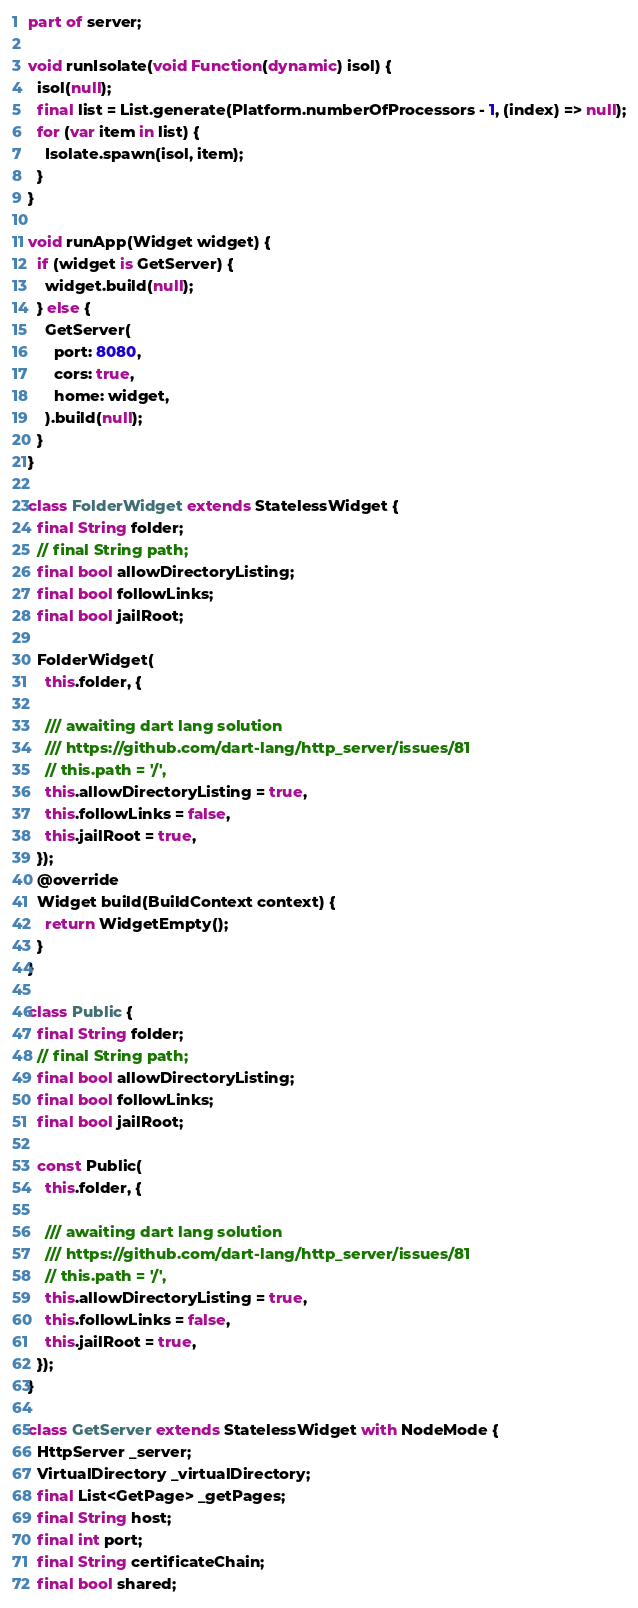Convert code to text. <code><loc_0><loc_0><loc_500><loc_500><_Dart_>part of server;

void runIsolate(void Function(dynamic) isol) {
  isol(null);
  final list = List.generate(Platform.numberOfProcessors - 1, (index) => null);
  for (var item in list) {
    Isolate.spawn(isol, item);
  }
}

void runApp(Widget widget) {
  if (widget is GetServer) {
    widget.build(null);
  } else {
    GetServer(
      port: 8080,
      cors: true,
      home: widget,
    ).build(null);
  }
}

class FolderWidget extends StatelessWidget {
  final String folder;
  // final String path;
  final bool allowDirectoryListing;
  final bool followLinks;
  final bool jailRoot;

  FolderWidget(
    this.folder, {

    /// awaiting dart lang solution
    /// https://github.com/dart-lang/http_server/issues/81
    // this.path = '/',
    this.allowDirectoryListing = true,
    this.followLinks = false,
    this.jailRoot = true,
  });
  @override
  Widget build(BuildContext context) {
    return WidgetEmpty();
  }
}

class Public {
  final String folder;
  // final String path;
  final bool allowDirectoryListing;
  final bool followLinks;
  final bool jailRoot;

  const Public(
    this.folder, {

    /// awaiting dart lang solution
    /// https://github.com/dart-lang/http_server/issues/81
    // this.path = '/',
    this.allowDirectoryListing = true,
    this.followLinks = false,
    this.jailRoot = true,
  });
}

class GetServer extends StatelessWidget with NodeMode {
  HttpServer _server;
  VirtualDirectory _virtualDirectory;
  final List<GetPage> _getPages;
  final String host;
  final int port;
  final String certificateChain;
  final bool shared;</code> 